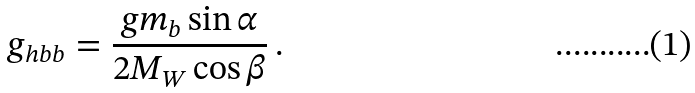<formula> <loc_0><loc_0><loc_500><loc_500>g _ { h b b } = \frac { g m _ { b } \sin \alpha } { 2 M _ { W } \cos \beta } \, .</formula> 